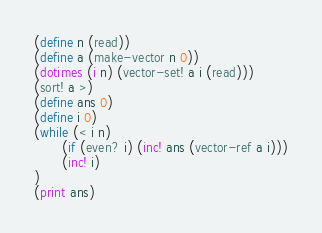<code> <loc_0><loc_0><loc_500><loc_500><_Scheme_>(define n (read))
(define a (make-vector n 0))
(dotimes (i n) (vector-set! a i (read)))
(sort! a >)
(define ans 0)
(define i 0)
(while (< i n)
       (if (even? i) (inc! ans (vector-ref a i)))
       (inc! i)
)
(print ans)</code> 